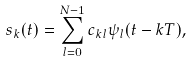Convert formula to latex. <formula><loc_0><loc_0><loc_500><loc_500>s _ { k } ( t ) = \sum _ { l = 0 } ^ { N - 1 } c _ { k l } \psi _ { l } ( t - k T ) ,</formula> 